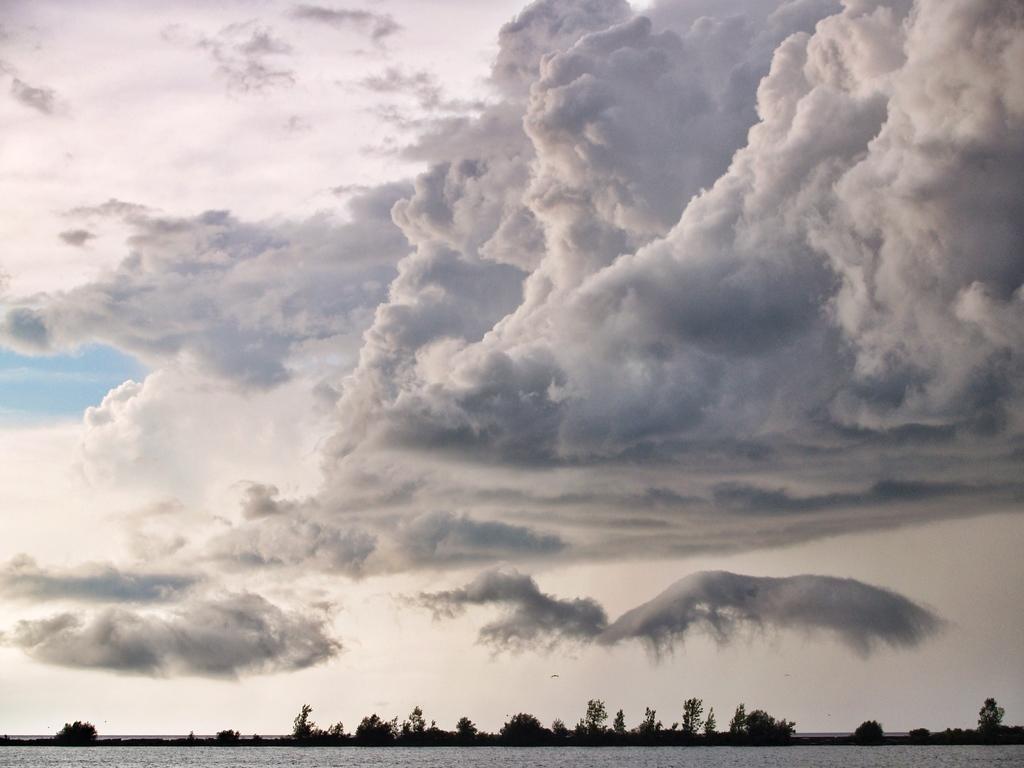Can you describe this image briefly? At the bottom of this image, there is water. In the background, there are trees on the ground and there are clouds in the sky. 